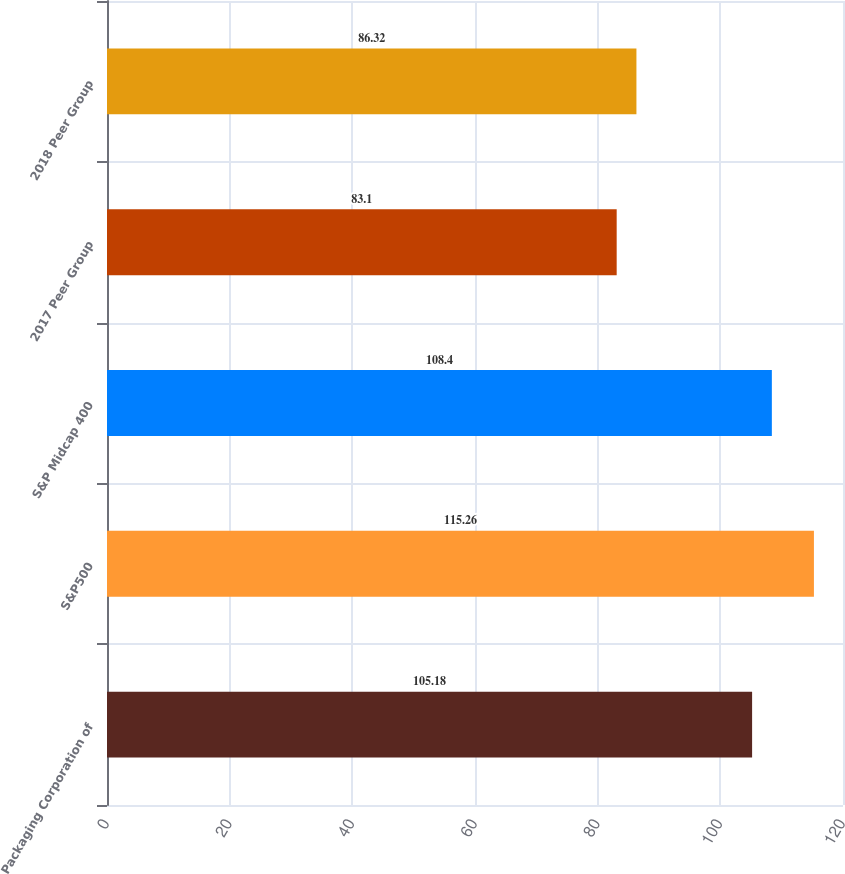<chart> <loc_0><loc_0><loc_500><loc_500><bar_chart><fcel>Packaging Corporation of<fcel>S&P500<fcel>S&P Midcap 400<fcel>2017 Peer Group<fcel>2018 Peer Group<nl><fcel>105.18<fcel>115.26<fcel>108.4<fcel>83.1<fcel>86.32<nl></chart> 